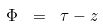Convert formula to latex. <formula><loc_0><loc_0><loc_500><loc_500>\Phi \ = \ \tau - z</formula> 